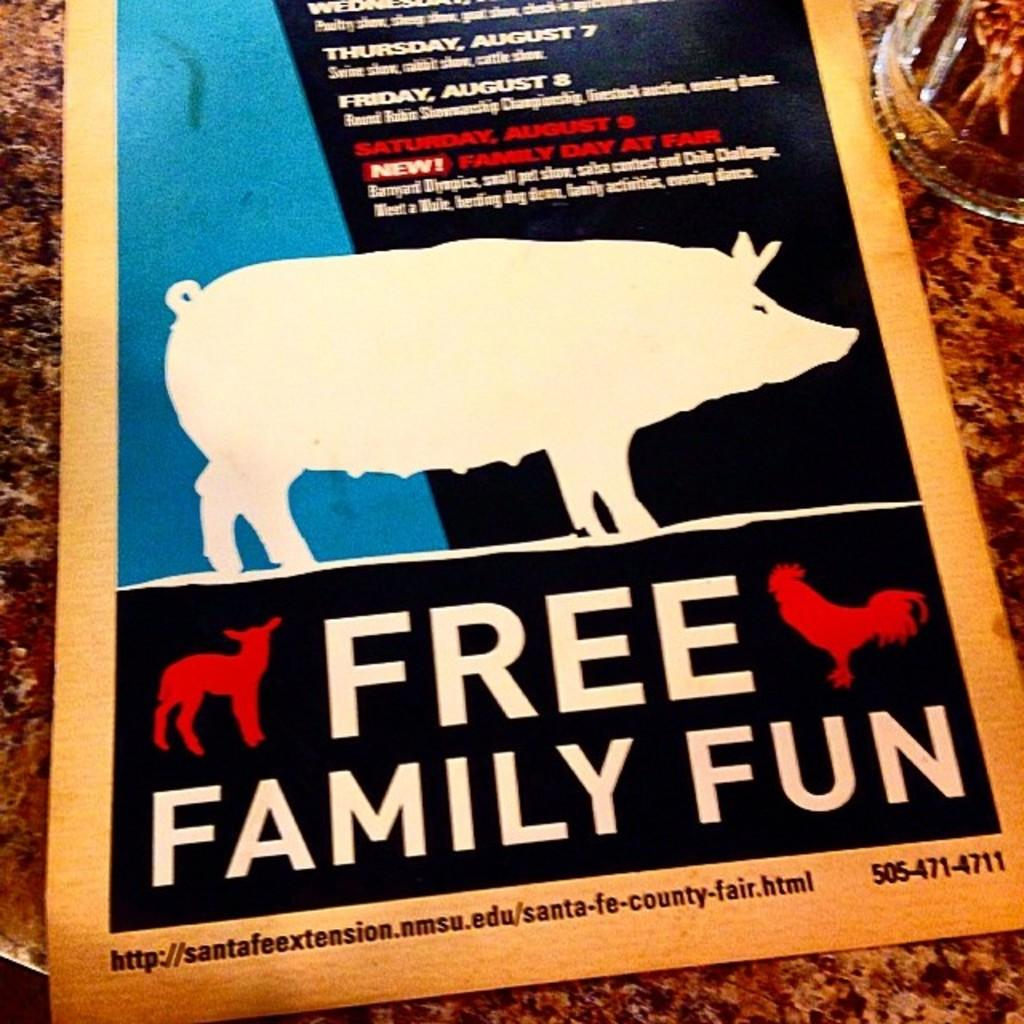What is the main object in the image? There is a card in the image. What is shown on the card? An animal is depicted on the card. How is the animal positioned on the card? The animal is standing. What else can be found on the card? There is text written on the card. What is the background color of the card? The card is on a brown color surface. What type of prison is shown in the image? There is no prison present in the image. The image only features a card with an animal standing on it, along with some text and a brown color surface. 